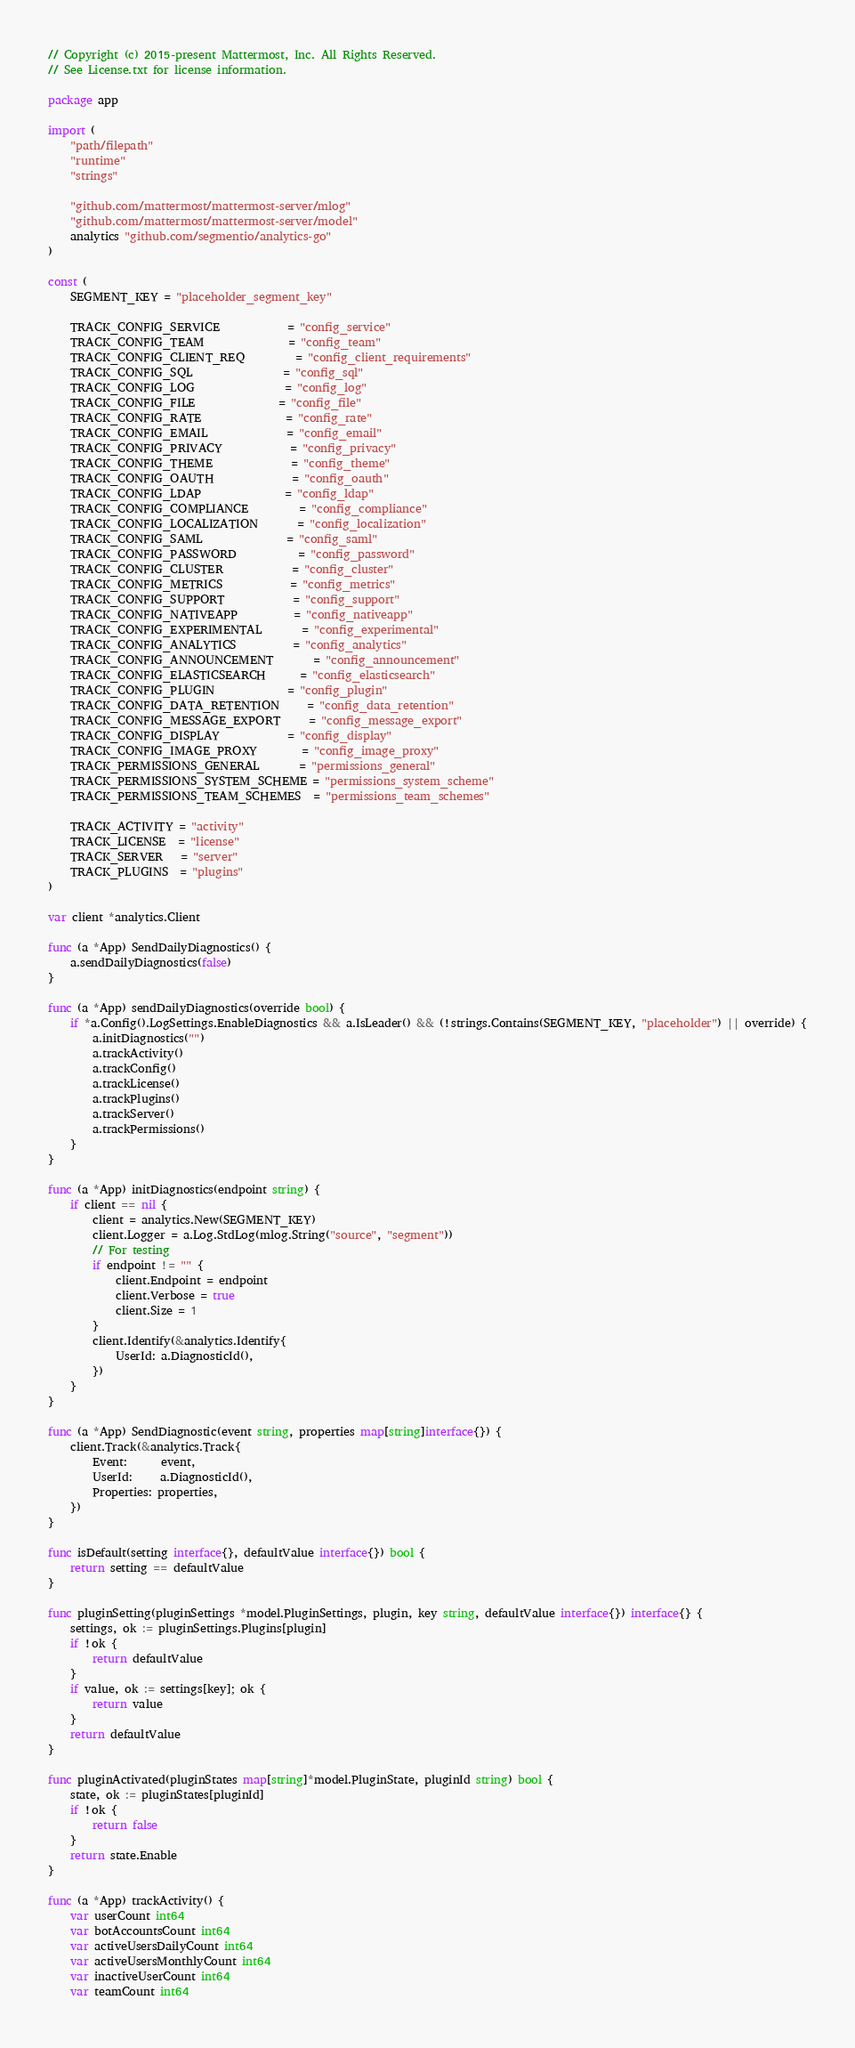<code> <loc_0><loc_0><loc_500><loc_500><_Go_>// Copyright (c) 2015-present Mattermost, Inc. All Rights Reserved.
// See License.txt for license information.

package app

import (
	"path/filepath"
	"runtime"
	"strings"

	"github.com/mattermost/mattermost-server/mlog"
	"github.com/mattermost/mattermost-server/model"
	analytics "github.com/segmentio/analytics-go"
)

const (
	SEGMENT_KEY = "placeholder_segment_key"

	TRACK_CONFIG_SERVICE            = "config_service"
	TRACK_CONFIG_TEAM               = "config_team"
	TRACK_CONFIG_CLIENT_REQ         = "config_client_requirements"
	TRACK_CONFIG_SQL                = "config_sql"
	TRACK_CONFIG_LOG                = "config_log"
	TRACK_CONFIG_FILE               = "config_file"
	TRACK_CONFIG_RATE               = "config_rate"
	TRACK_CONFIG_EMAIL              = "config_email"
	TRACK_CONFIG_PRIVACY            = "config_privacy"
	TRACK_CONFIG_THEME              = "config_theme"
	TRACK_CONFIG_OAUTH              = "config_oauth"
	TRACK_CONFIG_LDAP               = "config_ldap"
	TRACK_CONFIG_COMPLIANCE         = "config_compliance"
	TRACK_CONFIG_LOCALIZATION       = "config_localization"
	TRACK_CONFIG_SAML               = "config_saml"
	TRACK_CONFIG_PASSWORD           = "config_password"
	TRACK_CONFIG_CLUSTER            = "config_cluster"
	TRACK_CONFIG_METRICS            = "config_metrics"
	TRACK_CONFIG_SUPPORT            = "config_support"
	TRACK_CONFIG_NATIVEAPP          = "config_nativeapp"
	TRACK_CONFIG_EXPERIMENTAL       = "config_experimental"
	TRACK_CONFIG_ANALYTICS          = "config_analytics"
	TRACK_CONFIG_ANNOUNCEMENT       = "config_announcement"
	TRACK_CONFIG_ELASTICSEARCH      = "config_elasticsearch"
	TRACK_CONFIG_PLUGIN             = "config_plugin"
	TRACK_CONFIG_DATA_RETENTION     = "config_data_retention"
	TRACK_CONFIG_MESSAGE_EXPORT     = "config_message_export"
	TRACK_CONFIG_DISPLAY            = "config_display"
	TRACK_CONFIG_IMAGE_PROXY        = "config_image_proxy"
	TRACK_PERMISSIONS_GENERAL       = "permissions_general"
	TRACK_PERMISSIONS_SYSTEM_SCHEME = "permissions_system_scheme"
	TRACK_PERMISSIONS_TEAM_SCHEMES  = "permissions_team_schemes"

	TRACK_ACTIVITY = "activity"
	TRACK_LICENSE  = "license"
	TRACK_SERVER   = "server"
	TRACK_PLUGINS  = "plugins"
)

var client *analytics.Client

func (a *App) SendDailyDiagnostics() {
	a.sendDailyDiagnostics(false)
}

func (a *App) sendDailyDiagnostics(override bool) {
	if *a.Config().LogSettings.EnableDiagnostics && a.IsLeader() && (!strings.Contains(SEGMENT_KEY, "placeholder") || override) {
		a.initDiagnostics("")
		a.trackActivity()
		a.trackConfig()
		a.trackLicense()
		a.trackPlugins()
		a.trackServer()
		a.trackPermissions()
	}
}

func (a *App) initDiagnostics(endpoint string) {
	if client == nil {
		client = analytics.New(SEGMENT_KEY)
		client.Logger = a.Log.StdLog(mlog.String("source", "segment"))
		// For testing
		if endpoint != "" {
			client.Endpoint = endpoint
			client.Verbose = true
			client.Size = 1
		}
		client.Identify(&analytics.Identify{
			UserId: a.DiagnosticId(),
		})
	}
}

func (a *App) SendDiagnostic(event string, properties map[string]interface{}) {
	client.Track(&analytics.Track{
		Event:      event,
		UserId:     a.DiagnosticId(),
		Properties: properties,
	})
}

func isDefault(setting interface{}, defaultValue interface{}) bool {
	return setting == defaultValue
}

func pluginSetting(pluginSettings *model.PluginSettings, plugin, key string, defaultValue interface{}) interface{} {
	settings, ok := pluginSettings.Plugins[plugin]
	if !ok {
		return defaultValue
	}
	if value, ok := settings[key]; ok {
		return value
	}
	return defaultValue
}

func pluginActivated(pluginStates map[string]*model.PluginState, pluginId string) bool {
	state, ok := pluginStates[pluginId]
	if !ok {
		return false
	}
	return state.Enable
}

func (a *App) trackActivity() {
	var userCount int64
	var botAccountsCount int64
	var activeUsersDailyCount int64
	var activeUsersMonthlyCount int64
	var inactiveUserCount int64
	var teamCount int64</code> 